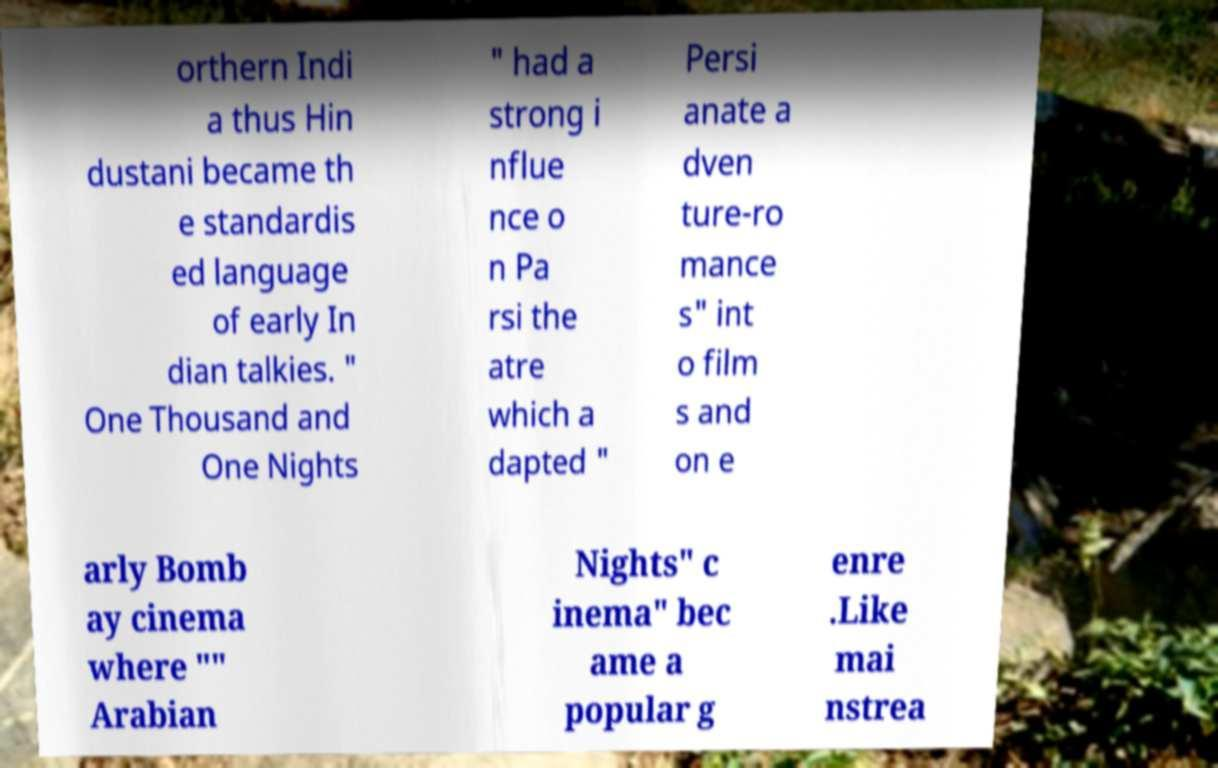Could you assist in decoding the text presented in this image and type it out clearly? orthern Indi a thus Hin dustani became th e standardis ed language of early In dian talkies. " One Thousand and One Nights " had a strong i nflue nce o n Pa rsi the atre which a dapted " Persi anate a dven ture-ro mance s" int o film s and on e arly Bomb ay cinema where "" Arabian Nights" c inema" bec ame a popular g enre .Like mai nstrea 